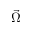<formula> <loc_0><loc_0><loc_500><loc_500>\vec { \Omega }</formula> 